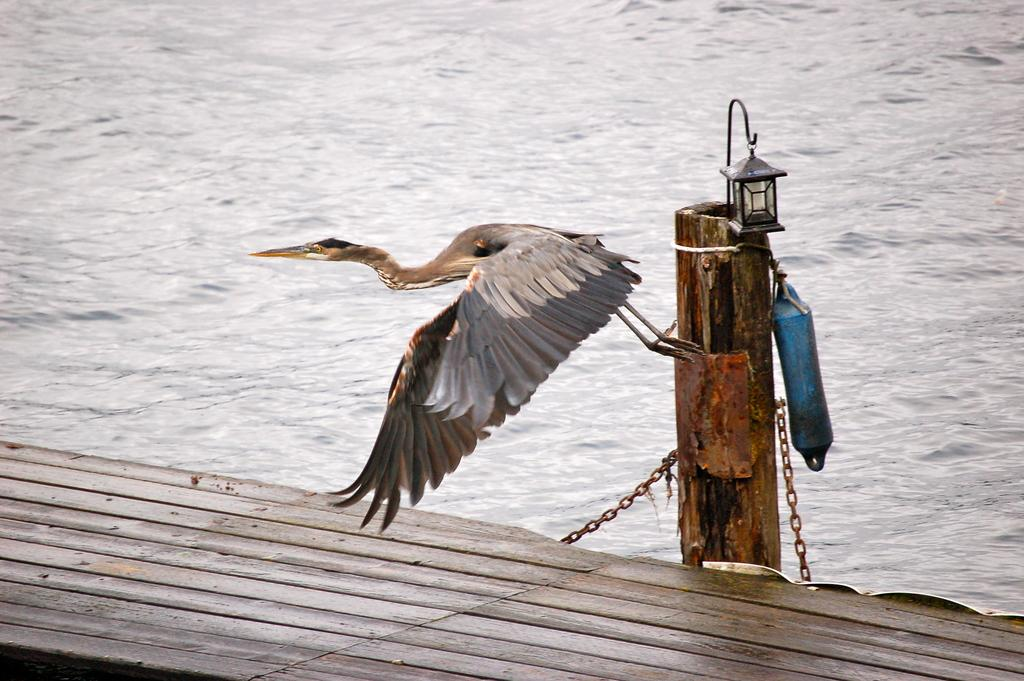What is located at the bottom of the image? There is a raft and a pile at the bottom of the image. What can be seen on the pole in the image? There are lights on a pole. What is visible behind the pole? Water is visible behind the pole. What is happening in the middle of the image? A bird is flying in the middle of the image. What type of seed is being planted by the cats in the image? There are no cats or seed present in the image. What route is the bird flying in the image? The image does not show the bird's flight path or route. 